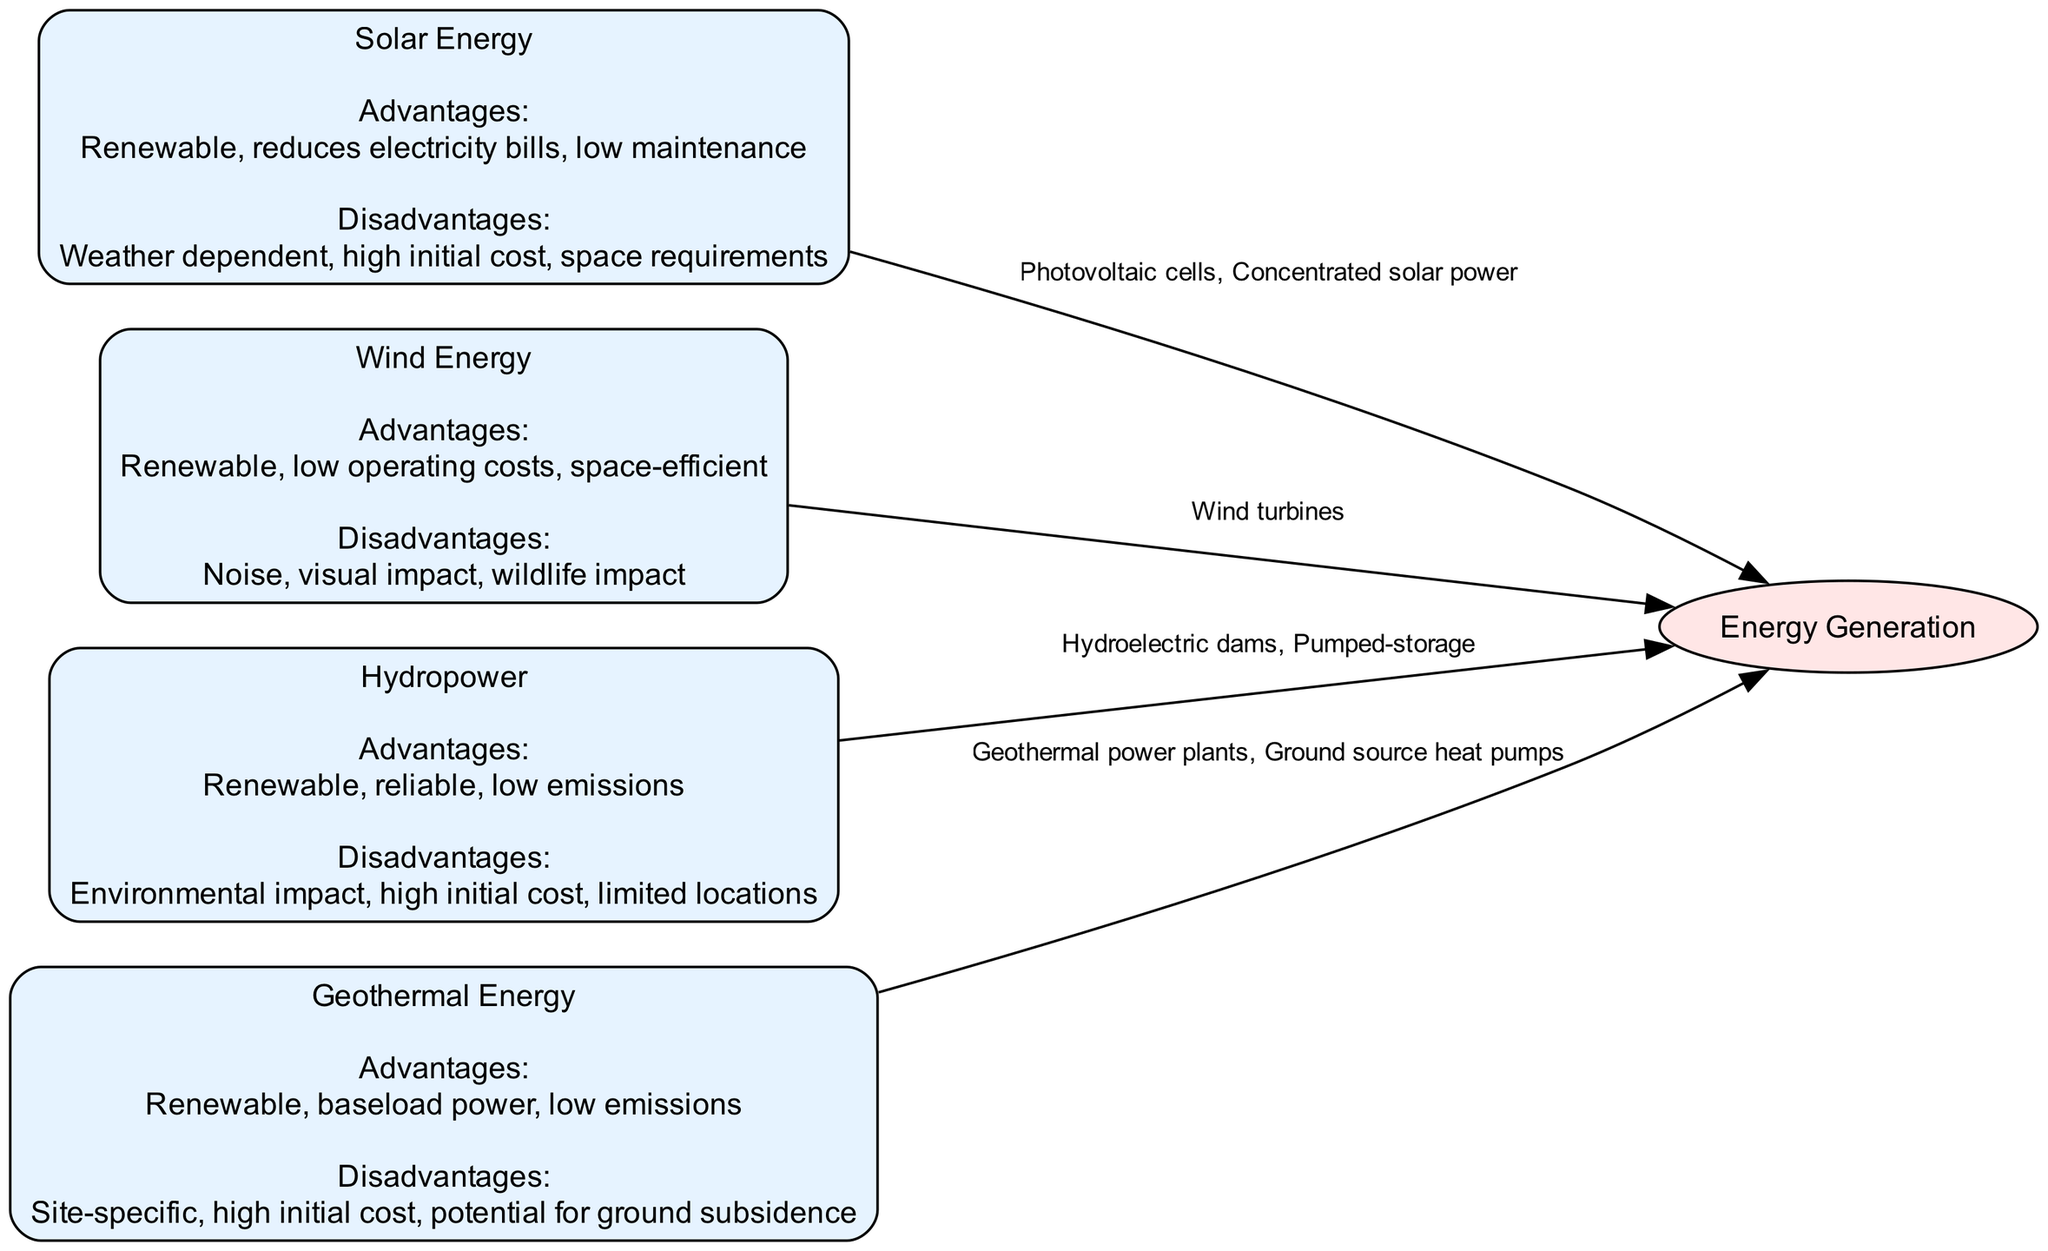What are the four types of renewable energy sources shown in the diagram? The diagram presents four nodes, each representing a different type of renewable energy: Solar Energy, Wind Energy, Hydropower, and Geothermal Energy.
Answer: Solar Energy, Wind Energy, Hydropower, Geothermal Energy Which energy source has the advantage of being space-efficient? Among the listed energy sources, Wind Energy is noted for its low operating costs and space efficiency as one of its advantages.
Answer: Wind Energy What disadvantage do all four renewable energy sources share? Each renewable energy source has high initial costs as a disadvantage, which highlights a common challenge faced when setting up these systems.
Answer: High initial cost What specific generation method is associated with Solar Energy? The diagram specifies that Solar Energy generates power through Photovoltaic cells and Concentrated solar power as its methods of energy generation.
Answer: Photovoltaic cells, Concentrated solar power Which energy type mentions environmental impact as a disadvantage? The Hydro source notes environmental impact as one of its disadvantages, indicating the potential negative effects it may have on surrounding ecosystems.
Answer: Hydropower How many nodes representing renewable energy sources are there in the diagram? The diagram includes four individual nodes that each represent a different type of renewable energy source, confirming the amount visually.
Answer: 4 Which energy source notes "potential for ground subsidence" as a disadvantage? The diagram indicates that Geothermal Energy specifically mentions the potential for ground subsidence as one of its disadvantages, highlighting site-specific risks.
Answer: Geothermal Energy What is the main advantage of Geothermal Energy? The primary advantage listed for Geothermal Energy is that it provides baseload power, which means it can consistently deliver energy.
Answer: Baseload power What type of energy generation is associated with wind energy? The diagram mentions that Wind Energy is generated specifically through Wind turbines, which are key components of wind energy systems.
Answer: Wind turbines 